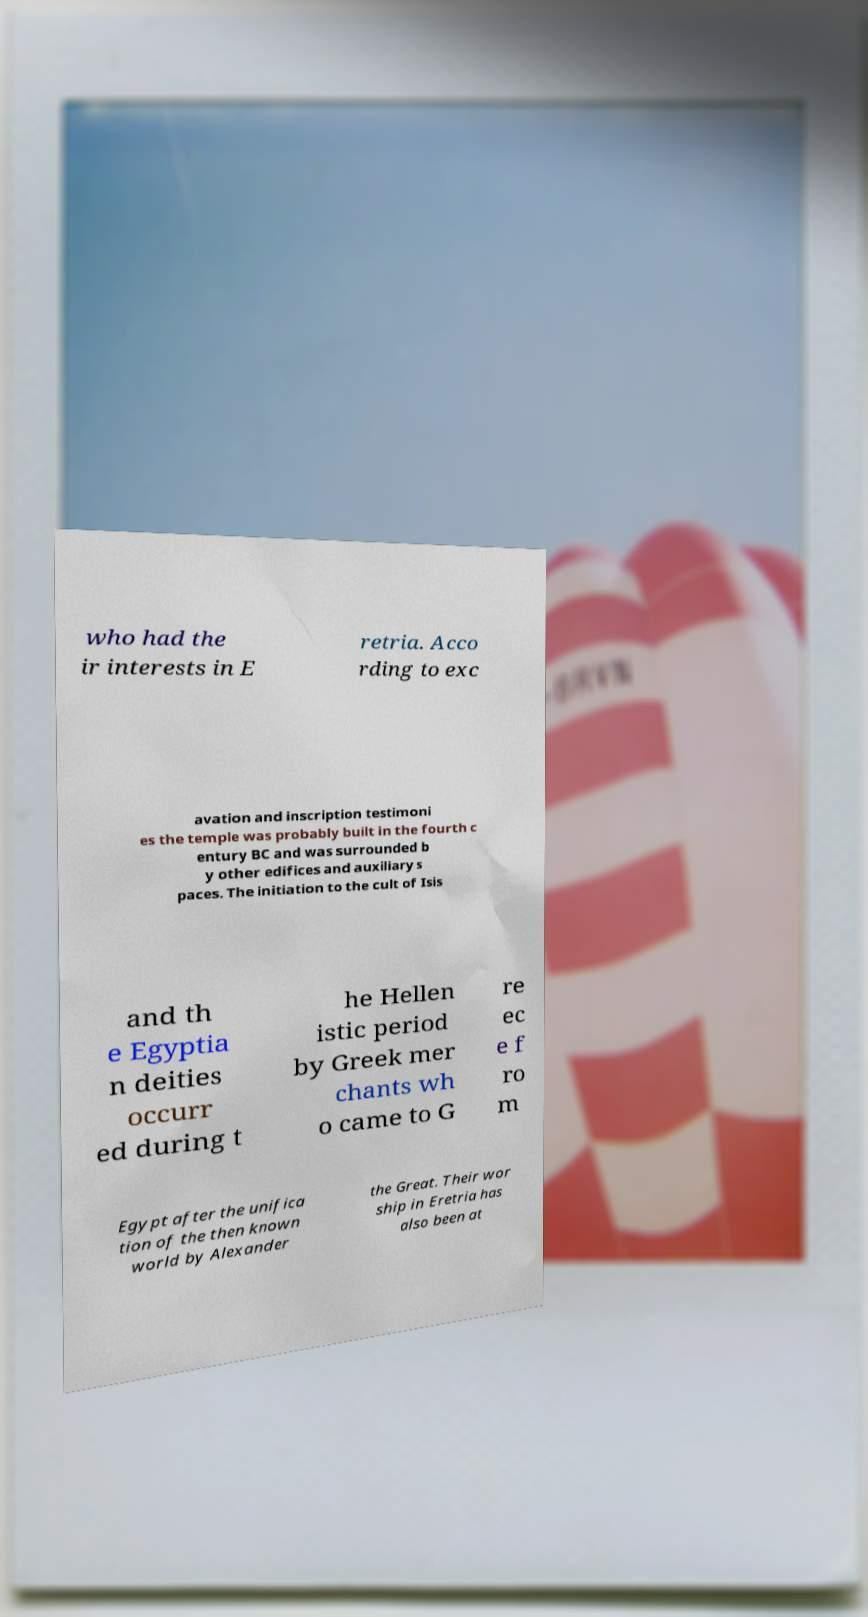Could you extract and type out the text from this image? who had the ir interests in E retria. Acco rding to exc avation and inscription testimoni es the temple was probably built in the fourth c entury BC and was surrounded b y other edifices and auxiliary s paces. The initiation to the cult of Isis and th e Egyptia n deities occurr ed during t he Hellen istic period by Greek mer chants wh o came to G re ec e f ro m Egypt after the unifica tion of the then known world by Alexander the Great. Their wor ship in Eretria has also been at 